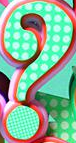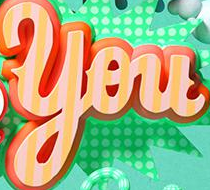Identify the words shown in these images in order, separated by a semicolon. ?; You 